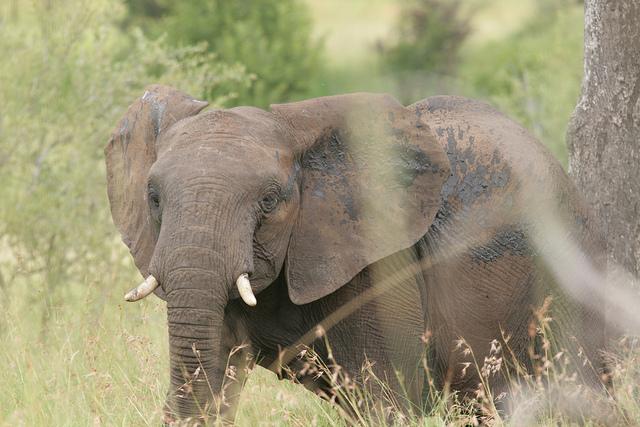What is the elephant doing?
Keep it brief. Walking. How is the elephant's ear?
Give a very brief answer. Big. What color is the tip of the elephant's ear?
Short answer required. Gray. Is this a baby animal?
Short answer required. Yes. Is the elephant alert?
Keep it brief. Yes. How many tusks are there?
Answer briefly. 2. How many elephants are in the picture?
Concise answer only. 1. What is on the elephant?
Concise answer only. Mud. 